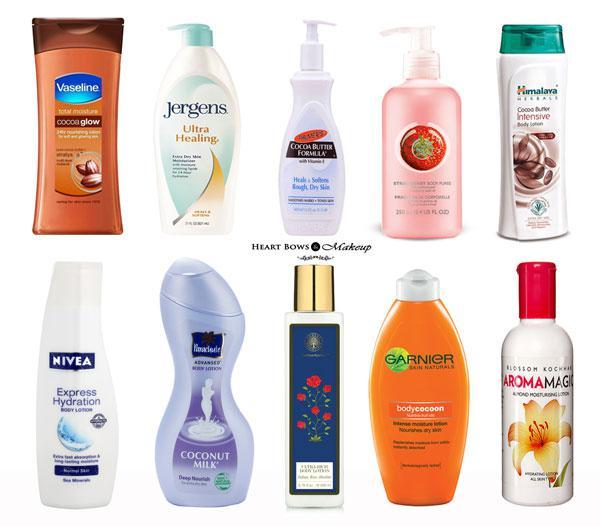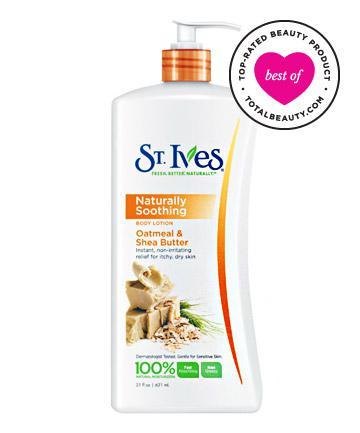The first image is the image on the left, the second image is the image on the right. For the images shown, is this caption "The images don't show the lotion being applied to anyone's skin." true? Answer yes or no. Yes. The first image is the image on the left, the second image is the image on the right. Analyze the images presented: Is the assertion "the left image is a single lotion bottle with a pump top" valid? Answer yes or no. No. 